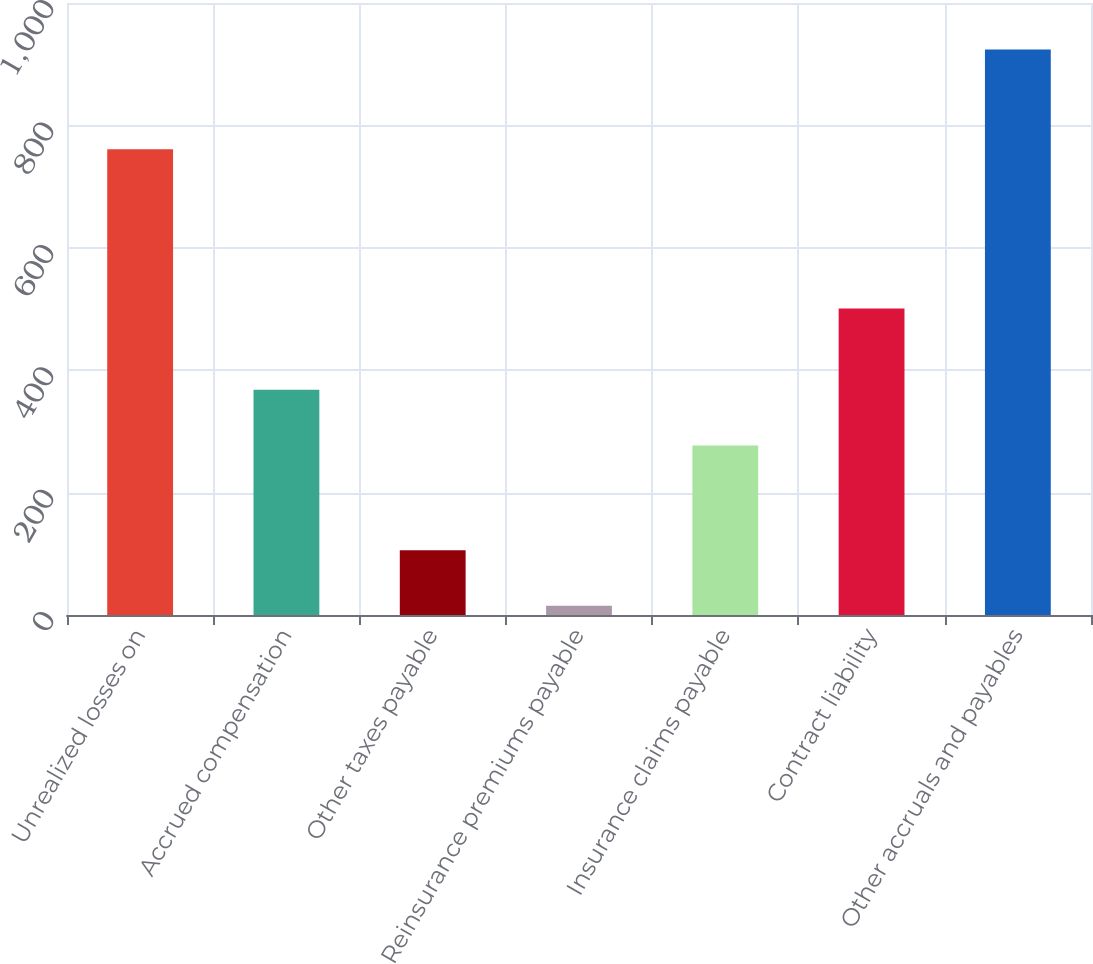<chart> <loc_0><loc_0><loc_500><loc_500><bar_chart><fcel>Unrealized losses on<fcel>Accrued compensation<fcel>Other taxes payable<fcel>Reinsurance premiums payable<fcel>Insurance claims payable<fcel>Contract liability<fcel>Other accruals and payables<nl><fcel>761<fcel>367.9<fcel>105.9<fcel>15<fcel>277<fcel>501<fcel>924<nl></chart> 